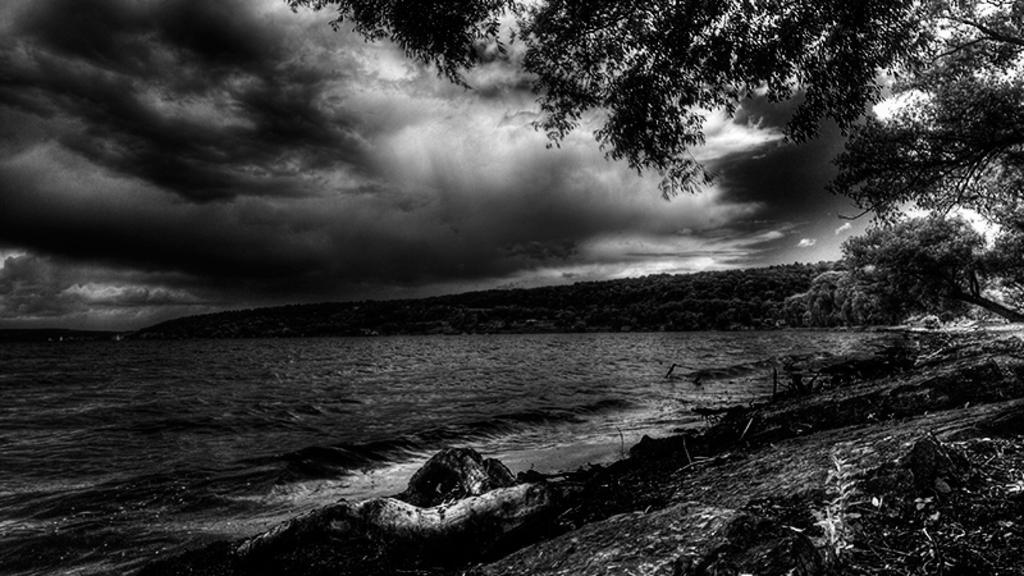In one or two sentences, can you explain what this image depicts? In this image there are trees on the right corner. There is ground. There is water on the left corner. There are objects that look like trees in the background. And it is dark and there are clouds in the sky. 